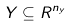Convert formula to latex. <formula><loc_0><loc_0><loc_500><loc_500>Y \subseteq R ^ { n _ { y } }</formula> 